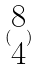Convert formula to latex. <formula><loc_0><loc_0><loc_500><loc_500>( \begin{matrix} 8 \\ 4 \end{matrix} )</formula> 